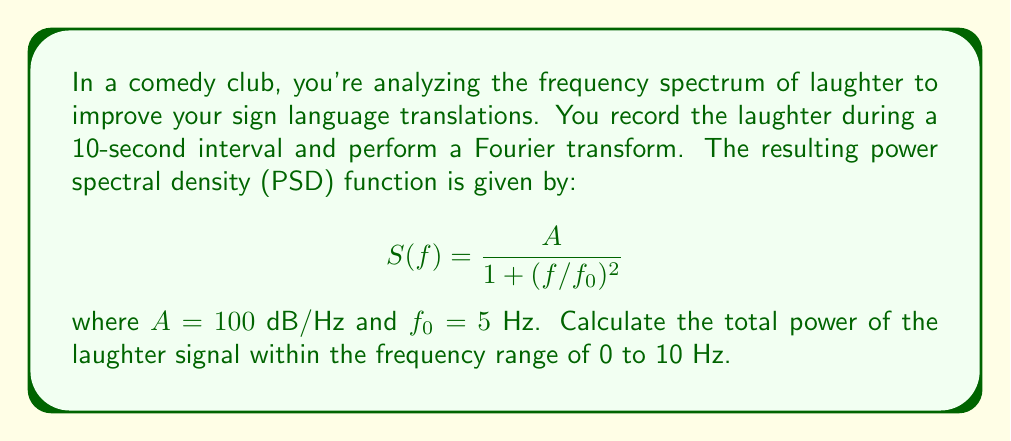Help me with this question. To solve this problem, we need to integrate the PSD function over the given frequency range. Here's the step-by-step solution:

1) The total power is given by the integral of the PSD function:

   $$P = \int_0^{10} S(f) df$$

2) Substituting the given PSD function:

   $$P = \int_0^{10} \frac{100}{1 + (f/5)^2} df$$

3) Let's make a substitution to simplify the integral. Let $u = f/5$, then $du = df/5$:

   $$P = 500 \int_0^2 \frac{1}{1 + u^2} du$$

4) This is the arctangent integral. The indefinite integral is:

   $$\int \frac{1}{1 + u^2} du = \arctan(u) + C$$

5) Applying the limits:

   $$P = 500 [\arctan(u)]_0^2$$

6) Evaluating:

   $$P = 500 [\arctan(2) - \arctan(0)]$$

7) $\arctan(0) = 0$, and $\arctan(2) \approx 1.1071$ radians:

   $$P \approx 500 \cdot 1.1071 \approx 553.55 \text{ dB}$$

Therefore, the total power of the laughter signal within the frequency range of 0 to 10 Hz is approximately 553.55 dB.
Answer: 553.55 dB 